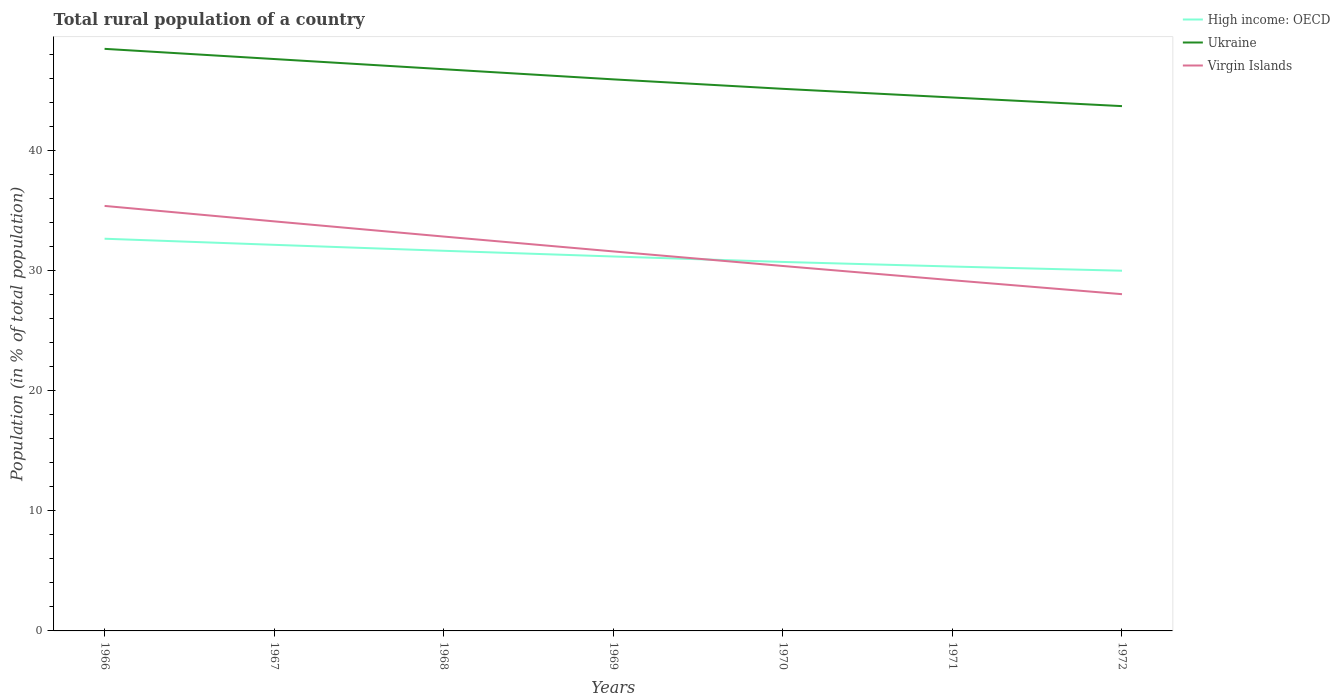How many different coloured lines are there?
Make the answer very short. 3. Is the number of lines equal to the number of legend labels?
Your answer should be compact. Yes. Across all years, what is the maximum rural population in Virgin Islands?
Ensure brevity in your answer.  28.06. In which year was the rural population in Virgin Islands maximum?
Provide a succinct answer. 1972. What is the total rural population in Virgin Islands in the graph?
Offer a very short reply. 1.16. What is the difference between the highest and the second highest rural population in Virgin Islands?
Your response must be concise. 7.35. What is the difference between the highest and the lowest rural population in Virgin Islands?
Keep it short and to the point. 3. Is the rural population in Virgin Islands strictly greater than the rural population in Ukraine over the years?
Your response must be concise. Yes. How many lines are there?
Offer a very short reply. 3. How many years are there in the graph?
Offer a very short reply. 7. Does the graph contain any zero values?
Offer a terse response. No. Does the graph contain grids?
Make the answer very short. No. What is the title of the graph?
Ensure brevity in your answer.  Total rural population of a country. Does "Middle East & North Africa (all income levels)" appear as one of the legend labels in the graph?
Provide a short and direct response. No. What is the label or title of the X-axis?
Offer a very short reply. Years. What is the label or title of the Y-axis?
Ensure brevity in your answer.  Population (in % of total population). What is the Population (in % of total population) of High income: OECD in 1966?
Give a very brief answer. 32.68. What is the Population (in % of total population) in Ukraine in 1966?
Make the answer very short. 48.5. What is the Population (in % of total population) of Virgin Islands in 1966?
Offer a very short reply. 35.41. What is the Population (in % of total population) in High income: OECD in 1967?
Offer a very short reply. 32.17. What is the Population (in % of total population) of Ukraine in 1967?
Offer a very short reply. 47.65. What is the Population (in % of total population) in Virgin Islands in 1967?
Provide a succinct answer. 34.13. What is the Population (in % of total population) of High income: OECD in 1968?
Your response must be concise. 31.67. What is the Population (in % of total population) in Ukraine in 1968?
Your answer should be compact. 46.8. What is the Population (in % of total population) in Virgin Islands in 1968?
Keep it short and to the point. 32.86. What is the Population (in % of total population) in High income: OECD in 1969?
Ensure brevity in your answer.  31.2. What is the Population (in % of total population) of Ukraine in 1969?
Provide a succinct answer. 45.96. What is the Population (in % of total population) of Virgin Islands in 1969?
Give a very brief answer. 31.62. What is the Population (in % of total population) in High income: OECD in 1970?
Your response must be concise. 30.74. What is the Population (in % of total population) in Ukraine in 1970?
Provide a short and direct response. 45.17. What is the Population (in % of total population) in Virgin Islands in 1970?
Keep it short and to the point. 30.41. What is the Population (in % of total population) in High income: OECD in 1971?
Give a very brief answer. 30.36. What is the Population (in % of total population) in Ukraine in 1971?
Offer a very short reply. 44.45. What is the Population (in % of total population) in Virgin Islands in 1971?
Give a very brief answer. 29.22. What is the Population (in % of total population) in High income: OECD in 1972?
Offer a very short reply. 30.01. What is the Population (in % of total population) in Ukraine in 1972?
Your answer should be very brief. 43.73. What is the Population (in % of total population) in Virgin Islands in 1972?
Offer a very short reply. 28.06. Across all years, what is the maximum Population (in % of total population) in High income: OECD?
Make the answer very short. 32.68. Across all years, what is the maximum Population (in % of total population) of Ukraine?
Make the answer very short. 48.5. Across all years, what is the maximum Population (in % of total population) of Virgin Islands?
Your answer should be compact. 35.41. Across all years, what is the minimum Population (in % of total population) of High income: OECD?
Your answer should be very brief. 30.01. Across all years, what is the minimum Population (in % of total population) of Ukraine?
Provide a short and direct response. 43.73. Across all years, what is the minimum Population (in % of total population) in Virgin Islands?
Your answer should be very brief. 28.06. What is the total Population (in % of total population) in High income: OECD in the graph?
Make the answer very short. 218.85. What is the total Population (in % of total population) in Ukraine in the graph?
Give a very brief answer. 322.26. What is the total Population (in % of total population) of Virgin Islands in the graph?
Keep it short and to the point. 221.71. What is the difference between the Population (in % of total population) in High income: OECD in 1966 and that in 1967?
Give a very brief answer. 0.51. What is the difference between the Population (in % of total population) of Ukraine in 1966 and that in 1967?
Offer a terse response. 0.85. What is the difference between the Population (in % of total population) of Virgin Islands in 1966 and that in 1967?
Your answer should be very brief. 1.29. What is the difference between the Population (in % of total population) in High income: OECD in 1966 and that in 1968?
Provide a short and direct response. 1.01. What is the difference between the Population (in % of total population) of Ukraine in 1966 and that in 1968?
Your response must be concise. 1.7. What is the difference between the Population (in % of total population) in Virgin Islands in 1966 and that in 1968?
Your answer should be very brief. 2.55. What is the difference between the Population (in % of total population) of High income: OECD in 1966 and that in 1969?
Keep it short and to the point. 1.48. What is the difference between the Population (in % of total population) in Ukraine in 1966 and that in 1969?
Give a very brief answer. 2.54. What is the difference between the Population (in % of total population) in Virgin Islands in 1966 and that in 1969?
Provide a short and direct response. 3.79. What is the difference between the Population (in % of total population) in High income: OECD in 1966 and that in 1970?
Your answer should be compact. 1.94. What is the difference between the Population (in % of total population) of Ukraine in 1966 and that in 1970?
Provide a short and direct response. 3.33. What is the difference between the Population (in % of total population) of Virgin Islands in 1966 and that in 1970?
Offer a terse response. 5. What is the difference between the Population (in % of total population) of High income: OECD in 1966 and that in 1971?
Ensure brevity in your answer.  2.32. What is the difference between the Population (in % of total population) of Ukraine in 1966 and that in 1971?
Offer a terse response. 4.05. What is the difference between the Population (in % of total population) in Virgin Islands in 1966 and that in 1971?
Provide a succinct answer. 6.19. What is the difference between the Population (in % of total population) in High income: OECD in 1966 and that in 1972?
Your answer should be very brief. 2.67. What is the difference between the Population (in % of total population) in Ukraine in 1966 and that in 1972?
Provide a succinct answer. 4.77. What is the difference between the Population (in % of total population) of Virgin Islands in 1966 and that in 1972?
Your answer should be compact. 7.35. What is the difference between the Population (in % of total population) of High income: OECD in 1967 and that in 1968?
Your answer should be very brief. 0.5. What is the difference between the Population (in % of total population) in Ukraine in 1967 and that in 1968?
Provide a short and direct response. 0.85. What is the difference between the Population (in % of total population) of Virgin Islands in 1967 and that in 1968?
Offer a very short reply. 1.27. What is the difference between the Population (in % of total population) of High income: OECD in 1967 and that in 1969?
Your answer should be very brief. 0.97. What is the difference between the Population (in % of total population) in Ukraine in 1967 and that in 1969?
Your answer should be very brief. 1.69. What is the difference between the Population (in % of total population) in Virgin Islands in 1967 and that in 1969?
Ensure brevity in your answer.  2.5. What is the difference between the Population (in % of total population) in High income: OECD in 1967 and that in 1970?
Make the answer very short. 1.43. What is the difference between the Population (in % of total population) of Ukraine in 1967 and that in 1970?
Your answer should be very brief. 2.48. What is the difference between the Population (in % of total population) in Virgin Islands in 1967 and that in 1970?
Offer a terse response. 3.72. What is the difference between the Population (in % of total population) of High income: OECD in 1967 and that in 1971?
Provide a succinct answer. 1.81. What is the difference between the Population (in % of total population) in Ukraine in 1967 and that in 1971?
Your response must be concise. 3.2. What is the difference between the Population (in % of total population) of Virgin Islands in 1967 and that in 1971?
Your answer should be very brief. 4.91. What is the difference between the Population (in % of total population) of High income: OECD in 1967 and that in 1972?
Provide a short and direct response. 2.16. What is the difference between the Population (in % of total population) in Ukraine in 1967 and that in 1972?
Offer a very short reply. 3.92. What is the difference between the Population (in % of total population) of Virgin Islands in 1967 and that in 1972?
Your response must be concise. 6.07. What is the difference between the Population (in % of total population) in High income: OECD in 1968 and that in 1969?
Your response must be concise. 0.47. What is the difference between the Population (in % of total population) of Ukraine in 1968 and that in 1969?
Provide a short and direct response. 0.84. What is the difference between the Population (in % of total population) of Virgin Islands in 1968 and that in 1969?
Provide a short and direct response. 1.24. What is the difference between the Population (in % of total population) of High income: OECD in 1968 and that in 1970?
Give a very brief answer. 0.93. What is the difference between the Population (in % of total population) of Ukraine in 1968 and that in 1970?
Give a very brief answer. 1.63. What is the difference between the Population (in % of total population) of Virgin Islands in 1968 and that in 1970?
Keep it short and to the point. 2.45. What is the difference between the Population (in % of total population) of High income: OECD in 1968 and that in 1971?
Your answer should be very brief. 1.31. What is the difference between the Population (in % of total population) of Ukraine in 1968 and that in 1971?
Your response must be concise. 2.35. What is the difference between the Population (in % of total population) of Virgin Islands in 1968 and that in 1971?
Offer a very short reply. 3.64. What is the difference between the Population (in % of total population) in High income: OECD in 1968 and that in 1972?
Provide a succinct answer. 1.66. What is the difference between the Population (in % of total population) in Ukraine in 1968 and that in 1972?
Offer a terse response. 3.08. What is the difference between the Population (in % of total population) in Virgin Islands in 1968 and that in 1972?
Keep it short and to the point. 4.8. What is the difference between the Population (in % of total population) of High income: OECD in 1969 and that in 1970?
Give a very brief answer. 0.46. What is the difference between the Population (in % of total population) in Ukraine in 1969 and that in 1970?
Give a very brief answer. 0.79. What is the difference between the Population (in % of total population) of Virgin Islands in 1969 and that in 1970?
Provide a short and direct response. 1.21. What is the difference between the Population (in % of total population) of High income: OECD in 1969 and that in 1971?
Your answer should be compact. 0.84. What is the difference between the Population (in % of total population) in Ukraine in 1969 and that in 1971?
Offer a very short reply. 1.51. What is the difference between the Population (in % of total population) in Virgin Islands in 1969 and that in 1971?
Offer a very short reply. 2.4. What is the difference between the Population (in % of total population) in High income: OECD in 1969 and that in 1972?
Provide a short and direct response. 1.19. What is the difference between the Population (in % of total population) in Ukraine in 1969 and that in 1972?
Your answer should be compact. 2.23. What is the difference between the Population (in % of total population) of Virgin Islands in 1969 and that in 1972?
Offer a terse response. 3.56. What is the difference between the Population (in % of total population) in High income: OECD in 1970 and that in 1971?
Make the answer very short. 0.38. What is the difference between the Population (in % of total population) of Ukraine in 1970 and that in 1971?
Ensure brevity in your answer.  0.72. What is the difference between the Population (in % of total population) in Virgin Islands in 1970 and that in 1971?
Your response must be concise. 1.19. What is the difference between the Population (in % of total population) of High income: OECD in 1970 and that in 1972?
Keep it short and to the point. 0.73. What is the difference between the Population (in % of total population) in Ukraine in 1970 and that in 1972?
Your answer should be compact. 1.44. What is the difference between the Population (in % of total population) of Virgin Islands in 1970 and that in 1972?
Your answer should be compact. 2.35. What is the difference between the Population (in % of total population) of High income: OECD in 1971 and that in 1972?
Offer a terse response. 0.35. What is the difference between the Population (in % of total population) in Ukraine in 1971 and that in 1972?
Make the answer very short. 0.72. What is the difference between the Population (in % of total population) in Virgin Islands in 1971 and that in 1972?
Provide a short and direct response. 1.16. What is the difference between the Population (in % of total population) of High income: OECD in 1966 and the Population (in % of total population) of Ukraine in 1967?
Keep it short and to the point. -14.97. What is the difference between the Population (in % of total population) in High income: OECD in 1966 and the Population (in % of total population) in Virgin Islands in 1967?
Ensure brevity in your answer.  -1.45. What is the difference between the Population (in % of total population) in Ukraine in 1966 and the Population (in % of total population) in Virgin Islands in 1967?
Keep it short and to the point. 14.38. What is the difference between the Population (in % of total population) in High income: OECD in 1966 and the Population (in % of total population) in Ukraine in 1968?
Your response must be concise. -14.12. What is the difference between the Population (in % of total population) of High income: OECD in 1966 and the Population (in % of total population) of Virgin Islands in 1968?
Your answer should be very brief. -0.18. What is the difference between the Population (in % of total population) in Ukraine in 1966 and the Population (in % of total population) in Virgin Islands in 1968?
Provide a short and direct response. 15.64. What is the difference between the Population (in % of total population) in High income: OECD in 1966 and the Population (in % of total population) in Ukraine in 1969?
Ensure brevity in your answer.  -13.28. What is the difference between the Population (in % of total population) of High income: OECD in 1966 and the Population (in % of total population) of Virgin Islands in 1969?
Offer a terse response. 1.06. What is the difference between the Population (in % of total population) in Ukraine in 1966 and the Population (in % of total population) in Virgin Islands in 1969?
Provide a short and direct response. 16.88. What is the difference between the Population (in % of total population) of High income: OECD in 1966 and the Population (in % of total population) of Ukraine in 1970?
Keep it short and to the point. -12.49. What is the difference between the Population (in % of total population) in High income: OECD in 1966 and the Population (in % of total population) in Virgin Islands in 1970?
Keep it short and to the point. 2.27. What is the difference between the Population (in % of total population) in Ukraine in 1966 and the Population (in % of total population) in Virgin Islands in 1970?
Provide a succinct answer. 18.09. What is the difference between the Population (in % of total population) in High income: OECD in 1966 and the Population (in % of total population) in Ukraine in 1971?
Offer a very short reply. -11.77. What is the difference between the Population (in % of total population) of High income: OECD in 1966 and the Population (in % of total population) of Virgin Islands in 1971?
Your response must be concise. 3.46. What is the difference between the Population (in % of total population) of Ukraine in 1966 and the Population (in % of total population) of Virgin Islands in 1971?
Offer a very short reply. 19.28. What is the difference between the Population (in % of total population) of High income: OECD in 1966 and the Population (in % of total population) of Ukraine in 1972?
Make the answer very short. -11.05. What is the difference between the Population (in % of total population) in High income: OECD in 1966 and the Population (in % of total population) in Virgin Islands in 1972?
Give a very brief answer. 4.62. What is the difference between the Population (in % of total population) of Ukraine in 1966 and the Population (in % of total population) of Virgin Islands in 1972?
Provide a succinct answer. 20.44. What is the difference between the Population (in % of total population) of High income: OECD in 1967 and the Population (in % of total population) of Ukraine in 1968?
Provide a succinct answer. -14.63. What is the difference between the Population (in % of total population) in High income: OECD in 1967 and the Population (in % of total population) in Virgin Islands in 1968?
Your response must be concise. -0.69. What is the difference between the Population (in % of total population) in Ukraine in 1967 and the Population (in % of total population) in Virgin Islands in 1968?
Offer a terse response. 14.79. What is the difference between the Population (in % of total population) in High income: OECD in 1967 and the Population (in % of total population) in Ukraine in 1969?
Make the answer very short. -13.79. What is the difference between the Population (in % of total population) of High income: OECD in 1967 and the Population (in % of total population) of Virgin Islands in 1969?
Your response must be concise. 0.55. What is the difference between the Population (in % of total population) in Ukraine in 1967 and the Population (in % of total population) in Virgin Islands in 1969?
Ensure brevity in your answer.  16.03. What is the difference between the Population (in % of total population) in High income: OECD in 1967 and the Population (in % of total population) in Ukraine in 1970?
Your response must be concise. -13. What is the difference between the Population (in % of total population) in High income: OECD in 1967 and the Population (in % of total population) in Virgin Islands in 1970?
Your answer should be compact. 1.76. What is the difference between the Population (in % of total population) of Ukraine in 1967 and the Population (in % of total population) of Virgin Islands in 1970?
Provide a short and direct response. 17.24. What is the difference between the Population (in % of total population) in High income: OECD in 1967 and the Population (in % of total population) in Ukraine in 1971?
Your response must be concise. -12.28. What is the difference between the Population (in % of total population) in High income: OECD in 1967 and the Population (in % of total population) in Virgin Islands in 1971?
Your answer should be compact. 2.95. What is the difference between the Population (in % of total population) in Ukraine in 1967 and the Population (in % of total population) in Virgin Islands in 1971?
Your answer should be compact. 18.43. What is the difference between the Population (in % of total population) in High income: OECD in 1967 and the Population (in % of total population) in Ukraine in 1972?
Give a very brief answer. -11.56. What is the difference between the Population (in % of total population) of High income: OECD in 1967 and the Population (in % of total population) of Virgin Islands in 1972?
Provide a short and direct response. 4.11. What is the difference between the Population (in % of total population) of Ukraine in 1967 and the Population (in % of total population) of Virgin Islands in 1972?
Provide a succinct answer. 19.59. What is the difference between the Population (in % of total population) in High income: OECD in 1968 and the Population (in % of total population) in Ukraine in 1969?
Give a very brief answer. -14.28. What is the difference between the Population (in % of total population) of High income: OECD in 1968 and the Population (in % of total population) of Virgin Islands in 1969?
Give a very brief answer. 0.05. What is the difference between the Population (in % of total population) of Ukraine in 1968 and the Population (in % of total population) of Virgin Islands in 1969?
Offer a terse response. 15.18. What is the difference between the Population (in % of total population) in High income: OECD in 1968 and the Population (in % of total population) in Ukraine in 1970?
Give a very brief answer. -13.49. What is the difference between the Population (in % of total population) of High income: OECD in 1968 and the Population (in % of total population) of Virgin Islands in 1970?
Keep it short and to the point. 1.27. What is the difference between the Population (in % of total population) in Ukraine in 1968 and the Population (in % of total population) in Virgin Islands in 1970?
Your answer should be very brief. 16.39. What is the difference between the Population (in % of total population) in High income: OECD in 1968 and the Population (in % of total population) in Ukraine in 1971?
Offer a very short reply. -12.77. What is the difference between the Population (in % of total population) of High income: OECD in 1968 and the Population (in % of total population) of Virgin Islands in 1971?
Provide a succinct answer. 2.45. What is the difference between the Population (in % of total population) in Ukraine in 1968 and the Population (in % of total population) in Virgin Islands in 1971?
Your response must be concise. 17.58. What is the difference between the Population (in % of total population) in High income: OECD in 1968 and the Population (in % of total population) in Ukraine in 1972?
Your answer should be very brief. -12.05. What is the difference between the Population (in % of total population) of High income: OECD in 1968 and the Population (in % of total population) of Virgin Islands in 1972?
Your answer should be very brief. 3.62. What is the difference between the Population (in % of total population) of Ukraine in 1968 and the Population (in % of total population) of Virgin Islands in 1972?
Your answer should be very brief. 18.74. What is the difference between the Population (in % of total population) of High income: OECD in 1969 and the Population (in % of total population) of Ukraine in 1970?
Provide a succinct answer. -13.97. What is the difference between the Population (in % of total population) in High income: OECD in 1969 and the Population (in % of total population) in Virgin Islands in 1970?
Provide a succinct answer. 0.79. What is the difference between the Population (in % of total population) of Ukraine in 1969 and the Population (in % of total population) of Virgin Islands in 1970?
Give a very brief answer. 15.55. What is the difference between the Population (in % of total population) in High income: OECD in 1969 and the Population (in % of total population) in Ukraine in 1971?
Provide a short and direct response. -13.25. What is the difference between the Population (in % of total population) in High income: OECD in 1969 and the Population (in % of total population) in Virgin Islands in 1971?
Your answer should be very brief. 1.98. What is the difference between the Population (in % of total population) of Ukraine in 1969 and the Population (in % of total population) of Virgin Islands in 1971?
Give a very brief answer. 16.74. What is the difference between the Population (in % of total population) of High income: OECD in 1969 and the Population (in % of total population) of Ukraine in 1972?
Keep it short and to the point. -12.53. What is the difference between the Population (in % of total population) in High income: OECD in 1969 and the Population (in % of total population) in Virgin Islands in 1972?
Keep it short and to the point. 3.14. What is the difference between the Population (in % of total population) in Ukraine in 1969 and the Population (in % of total population) in Virgin Islands in 1972?
Give a very brief answer. 17.9. What is the difference between the Population (in % of total population) in High income: OECD in 1970 and the Population (in % of total population) in Ukraine in 1971?
Keep it short and to the point. -13.7. What is the difference between the Population (in % of total population) in High income: OECD in 1970 and the Population (in % of total population) in Virgin Islands in 1971?
Offer a very short reply. 1.52. What is the difference between the Population (in % of total population) in Ukraine in 1970 and the Population (in % of total population) in Virgin Islands in 1971?
Offer a very short reply. 15.95. What is the difference between the Population (in % of total population) in High income: OECD in 1970 and the Population (in % of total population) in Ukraine in 1972?
Offer a very short reply. -12.98. What is the difference between the Population (in % of total population) in High income: OECD in 1970 and the Population (in % of total population) in Virgin Islands in 1972?
Give a very brief answer. 2.69. What is the difference between the Population (in % of total population) in Ukraine in 1970 and the Population (in % of total population) in Virgin Islands in 1972?
Offer a terse response. 17.11. What is the difference between the Population (in % of total population) in High income: OECD in 1971 and the Population (in % of total population) in Ukraine in 1972?
Provide a short and direct response. -13.37. What is the difference between the Population (in % of total population) of High income: OECD in 1971 and the Population (in % of total population) of Virgin Islands in 1972?
Offer a terse response. 2.3. What is the difference between the Population (in % of total population) of Ukraine in 1971 and the Population (in % of total population) of Virgin Islands in 1972?
Provide a succinct answer. 16.39. What is the average Population (in % of total population) of High income: OECD per year?
Provide a short and direct response. 31.26. What is the average Population (in % of total population) of Ukraine per year?
Offer a terse response. 46.04. What is the average Population (in % of total population) of Virgin Islands per year?
Make the answer very short. 31.67. In the year 1966, what is the difference between the Population (in % of total population) of High income: OECD and Population (in % of total population) of Ukraine?
Give a very brief answer. -15.82. In the year 1966, what is the difference between the Population (in % of total population) in High income: OECD and Population (in % of total population) in Virgin Islands?
Your response must be concise. -2.73. In the year 1966, what is the difference between the Population (in % of total population) of Ukraine and Population (in % of total population) of Virgin Islands?
Ensure brevity in your answer.  13.09. In the year 1967, what is the difference between the Population (in % of total population) of High income: OECD and Population (in % of total population) of Ukraine?
Make the answer very short. -15.48. In the year 1967, what is the difference between the Population (in % of total population) in High income: OECD and Population (in % of total population) in Virgin Islands?
Provide a succinct answer. -1.96. In the year 1967, what is the difference between the Population (in % of total population) of Ukraine and Population (in % of total population) of Virgin Islands?
Your answer should be very brief. 13.53. In the year 1968, what is the difference between the Population (in % of total population) in High income: OECD and Population (in % of total population) in Ukraine?
Ensure brevity in your answer.  -15.13. In the year 1968, what is the difference between the Population (in % of total population) in High income: OECD and Population (in % of total population) in Virgin Islands?
Offer a very short reply. -1.19. In the year 1968, what is the difference between the Population (in % of total population) in Ukraine and Population (in % of total population) in Virgin Islands?
Offer a terse response. 13.94. In the year 1969, what is the difference between the Population (in % of total population) of High income: OECD and Population (in % of total population) of Ukraine?
Your answer should be compact. -14.76. In the year 1969, what is the difference between the Population (in % of total population) of High income: OECD and Population (in % of total population) of Virgin Islands?
Ensure brevity in your answer.  -0.42. In the year 1969, what is the difference between the Population (in % of total population) of Ukraine and Population (in % of total population) of Virgin Islands?
Provide a short and direct response. 14.34. In the year 1970, what is the difference between the Population (in % of total population) in High income: OECD and Population (in % of total population) in Ukraine?
Offer a terse response. -14.42. In the year 1970, what is the difference between the Population (in % of total population) in High income: OECD and Population (in % of total population) in Virgin Islands?
Make the answer very short. 0.34. In the year 1970, what is the difference between the Population (in % of total population) of Ukraine and Population (in % of total population) of Virgin Islands?
Give a very brief answer. 14.76. In the year 1971, what is the difference between the Population (in % of total population) of High income: OECD and Population (in % of total population) of Ukraine?
Give a very brief answer. -14.09. In the year 1971, what is the difference between the Population (in % of total population) of High income: OECD and Population (in % of total population) of Virgin Islands?
Provide a succinct answer. 1.14. In the year 1971, what is the difference between the Population (in % of total population) in Ukraine and Population (in % of total population) in Virgin Islands?
Your answer should be compact. 15.23. In the year 1972, what is the difference between the Population (in % of total population) in High income: OECD and Population (in % of total population) in Ukraine?
Make the answer very short. -13.71. In the year 1972, what is the difference between the Population (in % of total population) in High income: OECD and Population (in % of total population) in Virgin Islands?
Your answer should be compact. 1.95. In the year 1972, what is the difference between the Population (in % of total population) in Ukraine and Population (in % of total population) in Virgin Islands?
Make the answer very short. 15.67. What is the ratio of the Population (in % of total population) in High income: OECD in 1966 to that in 1967?
Give a very brief answer. 1.02. What is the ratio of the Population (in % of total population) in Ukraine in 1966 to that in 1967?
Make the answer very short. 1.02. What is the ratio of the Population (in % of total population) of Virgin Islands in 1966 to that in 1967?
Keep it short and to the point. 1.04. What is the ratio of the Population (in % of total population) in High income: OECD in 1966 to that in 1968?
Give a very brief answer. 1.03. What is the ratio of the Population (in % of total population) of Ukraine in 1966 to that in 1968?
Your answer should be compact. 1.04. What is the ratio of the Population (in % of total population) in Virgin Islands in 1966 to that in 1968?
Your response must be concise. 1.08. What is the ratio of the Population (in % of total population) in High income: OECD in 1966 to that in 1969?
Offer a very short reply. 1.05. What is the ratio of the Population (in % of total population) in Ukraine in 1966 to that in 1969?
Offer a very short reply. 1.06. What is the ratio of the Population (in % of total population) in Virgin Islands in 1966 to that in 1969?
Make the answer very short. 1.12. What is the ratio of the Population (in % of total population) of High income: OECD in 1966 to that in 1970?
Offer a terse response. 1.06. What is the ratio of the Population (in % of total population) in Ukraine in 1966 to that in 1970?
Make the answer very short. 1.07. What is the ratio of the Population (in % of total population) of Virgin Islands in 1966 to that in 1970?
Keep it short and to the point. 1.16. What is the ratio of the Population (in % of total population) of High income: OECD in 1966 to that in 1971?
Ensure brevity in your answer.  1.08. What is the ratio of the Population (in % of total population) of Ukraine in 1966 to that in 1971?
Make the answer very short. 1.09. What is the ratio of the Population (in % of total population) in Virgin Islands in 1966 to that in 1971?
Your answer should be compact. 1.21. What is the ratio of the Population (in % of total population) of High income: OECD in 1966 to that in 1972?
Ensure brevity in your answer.  1.09. What is the ratio of the Population (in % of total population) in Ukraine in 1966 to that in 1972?
Provide a short and direct response. 1.11. What is the ratio of the Population (in % of total population) in Virgin Islands in 1966 to that in 1972?
Give a very brief answer. 1.26. What is the ratio of the Population (in % of total population) of High income: OECD in 1967 to that in 1968?
Your answer should be very brief. 1.02. What is the ratio of the Population (in % of total population) in Ukraine in 1967 to that in 1968?
Your answer should be compact. 1.02. What is the ratio of the Population (in % of total population) in Virgin Islands in 1967 to that in 1968?
Provide a short and direct response. 1.04. What is the ratio of the Population (in % of total population) of High income: OECD in 1967 to that in 1969?
Give a very brief answer. 1.03. What is the ratio of the Population (in % of total population) of Ukraine in 1967 to that in 1969?
Give a very brief answer. 1.04. What is the ratio of the Population (in % of total population) in Virgin Islands in 1967 to that in 1969?
Offer a very short reply. 1.08. What is the ratio of the Population (in % of total population) of High income: OECD in 1967 to that in 1970?
Provide a succinct answer. 1.05. What is the ratio of the Population (in % of total population) in Ukraine in 1967 to that in 1970?
Offer a terse response. 1.05. What is the ratio of the Population (in % of total population) in Virgin Islands in 1967 to that in 1970?
Offer a terse response. 1.12. What is the ratio of the Population (in % of total population) in High income: OECD in 1967 to that in 1971?
Your answer should be very brief. 1.06. What is the ratio of the Population (in % of total population) of Ukraine in 1967 to that in 1971?
Give a very brief answer. 1.07. What is the ratio of the Population (in % of total population) in Virgin Islands in 1967 to that in 1971?
Your answer should be very brief. 1.17. What is the ratio of the Population (in % of total population) in High income: OECD in 1967 to that in 1972?
Provide a short and direct response. 1.07. What is the ratio of the Population (in % of total population) of Ukraine in 1967 to that in 1972?
Your response must be concise. 1.09. What is the ratio of the Population (in % of total population) of Virgin Islands in 1967 to that in 1972?
Your answer should be very brief. 1.22. What is the ratio of the Population (in % of total population) of High income: OECD in 1968 to that in 1969?
Offer a terse response. 1.02. What is the ratio of the Population (in % of total population) in Ukraine in 1968 to that in 1969?
Your response must be concise. 1.02. What is the ratio of the Population (in % of total population) of Virgin Islands in 1968 to that in 1969?
Your answer should be compact. 1.04. What is the ratio of the Population (in % of total population) in High income: OECD in 1968 to that in 1970?
Provide a succinct answer. 1.03. What is the ratio of the Population (in % of total population) in Ukraine in 1968 to that in 1970?
Keep it short and to the point. 1.04. What is the ratio of the Population (in % of total population) in Virgin Islands in 1968 to that in 1970?
Your answer should be compact. 1.08. What is the ratio of the Population (in % of total population) in High income: OECD in 1968 to that in 1971?
Ensure brevity in your answer.  1.04. What is the ratio of the Population (in % of total population) of Ukraine in 1968 to that in 1971?
Ensure brevity in your answer.  1.05. What is the ratio of the Population (in % of total population) in Virgin Islands in 1968 to that in 1971?
Keep it short and to the point. 1.12. What is the ratio of the Population (in % of total population) of High income: OECD in 1968 to that in 1972?
Ensure brevity in your answer.  1.06. What is the ratio of the Population (in % of total population) of Ukraine in 1968 to that in 1972?
Ensure brevity in your answer.  1.07. What is the ratio of the Population (in % of total population) of Virgin Islands in 1968 to that in 1972?
Give a very brief answer. 1.17. What is the ratio of the Population (in % of total population) of High income: OECD in 1969 to that in 1970?
Offer a terse response. 1.01. What is the ratio of the Population (in % of total population) of Ukraine in 1969 to that in 1970?
Give a very brief answer. 1.02. What is the ratio of the Population (in % of total population) in Virgin Islands in 1969 to that in 1970?
Your response must be concise. 1.04. What is the ratio of the Population (in % of total population) in High income: OECD in 1969 to that in 1971?
Make the answer very short. 1.03. What is the ratio of the Population (in % of total population) in Ukraine in 1969 to that in 1971?
Provide a succinct answer. 1.03. What is the ratio of the Population (in % of total population) of Virgin Islands in 1969 to that in 1971?
Your answer should be compact. 1.08. What is the ratio of the Population (in % of total population) in High income: OECD in 1969 to that in 1972?
Ensure brevity in your answer.  1.04. What is the ratio of the Population (in % of total population) in Ukraine in 1969 to that in 1972?
Make the answer very short. 1.05. What is the ratio of the Population (in % of total population) in Virgin Islands in 1969 to that in 1972?
Keep it short and to the point. 1.13. What is the ratio of the Population (in % of total population) in High income: OECD in 1970 to that in 1971?
Your answer should be very brief. 1.01. What is the ratio of the Population (in % of total population) in Ukraine in 1970 to that in 1971?
Your response must be concise. 1.02. What is the ratio of the Population (in % of total population) in Virgin Islands in 1970 to that in 1971?
Your answer should be compact. 1.04. What is the ratio of the Population (in % of total population) in High income: OECD in 1970 to that in 1972?
Offer a very short reply. 1.02. What is the ratio of the Population (in % of total population) in Ukraine in 1970 to that in 1972?
Offer a very short reply. 1.03. What is the ratio of the Population (in % of total population) of Virgin Islands in 1970 to that in 1972?
Your answer should be very brief. 1.08. What is the ratio of the Population (in % of total population) in High income: OECD in 1971 to that in 1972?
Your answer should be very brief. 1.01. What is the ratio of the Population (in % of total population) of Ukraine in 1971 to that in 1972?
Make the answer very short. 1.02. What is the ratio of the Population (in % of total population) of Virgin Islands in 1971 to that in 1972?
Your answer should be very brief. 1.04. What is the difference between the highest and the second highest Population (in % of total population) of High income: OECD?
Your response must be concise. 0.51. What is the difference between the highest and the second highest Population (in % of total population) of Ukraine?
Offer a very short reply. 0.85. What is the difference between the highest and the second highest Population (in % of total population) in Virgin Islands?
Your answer should be very brief. 1.29. What is the difference between the highest and the lowest Population (in % of total population) in High income: OECD?
Provide a short and direct response. 2.67. What is the difference between the highest and the lowest Population (in % of total population) of Ukraine?
Provide a succinct answer. 4.77. What is the difference between the highest and the lowest Population (in % of total population) of Virgin Islands?
Offer a terse response. 7.35. 